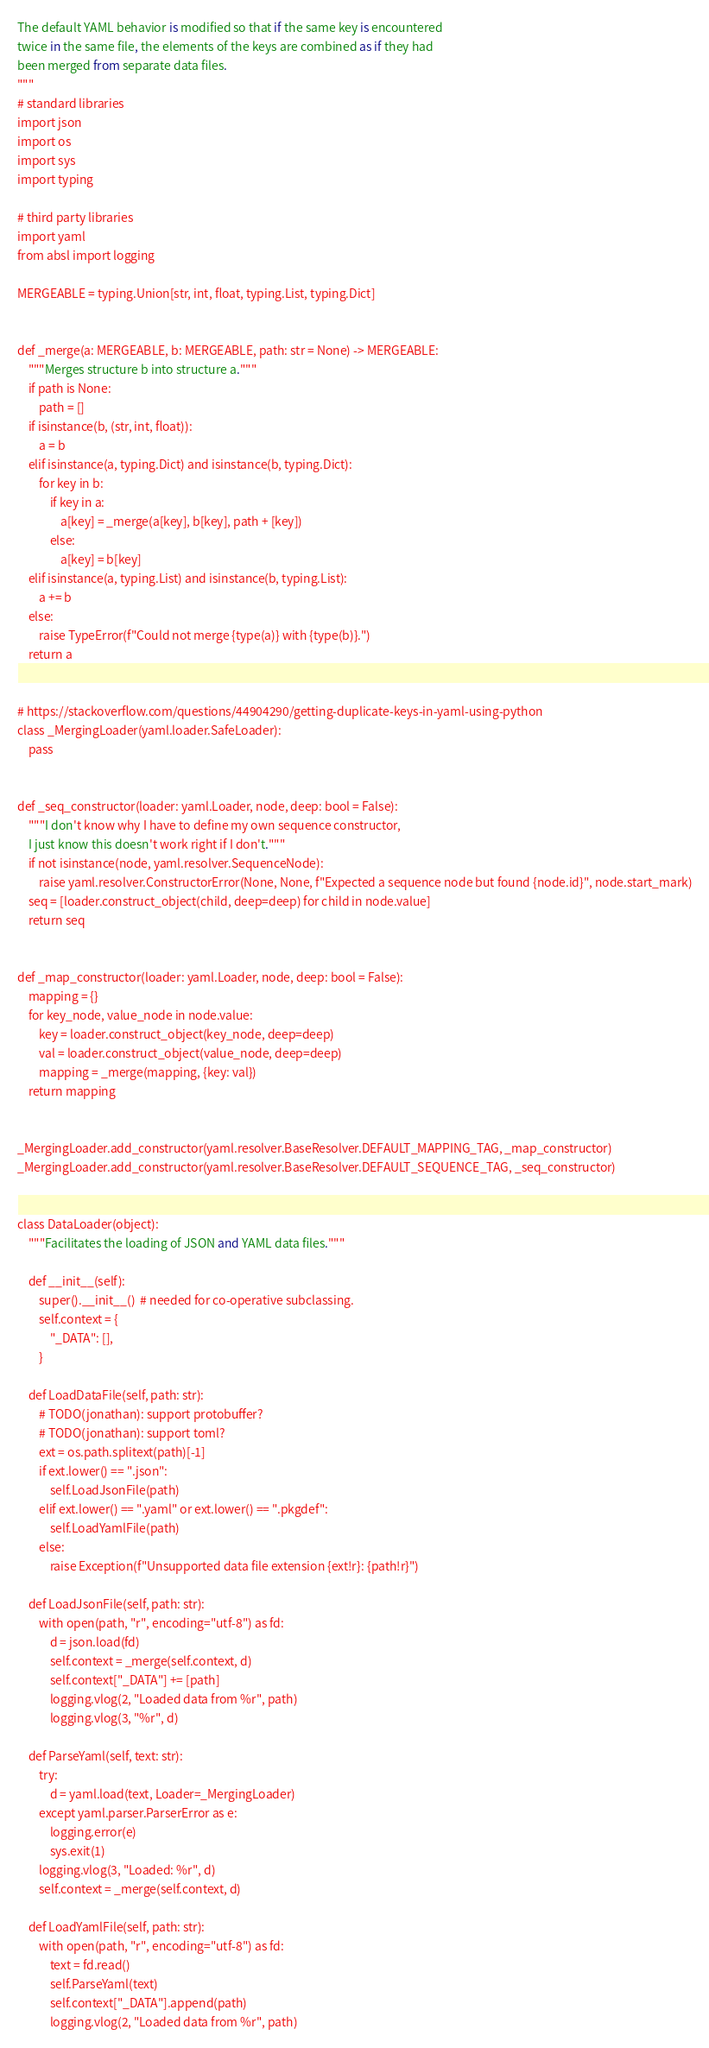<code> <loc_0><loc_0><loc_500><loc_500><_Python_>
The default YAML behavior is modified so that if the same key is encountered
twice in the same file, the elements of the keys are combined as if they had
been merged from separate data files.
"""
# standard libraries
import json
import os
import sys
import typing

# third party libraries
import yaml
from absl import logging

MERGEABLE = typing.Union[str, int, float, typing.List, typing.Dict]


def _merge(a: MERGEABLE, b: MERGEABLE, path: str = None) -> MERGEABLE:
    """Merges structure b into structure a."""
    if path is None:
        path = []
    if isinstance(b, (str, int, float)):
        a = b
    elif isinstance(a, typing.Dict) and isinstance(b, typing.Dict):
        for key in b:
            if key in a:
                a[key] = _merge(a[key], b[key], path + [key])
            else:
                a[key] = b[key]
    elif isinstance(a, typing.List) and isinstance(b, typing.List):
        a += b
    else:
        raise TypeError(f"Could not merge {type(a)} with {type(b)}.")
    return a


# https://stackoverflow.com/questions/44904290/getting-duplicate-keys-in-yaml-using-python
class _MergingLoader(yaml.loader.SafeLoader):
    pass


def _seq_constructor(loader: yaml.Loader, node, deep: bool = False):
    """I don't know why I have to define my own sequence constructor,
    I just know this doesn't work right if I don't."""
    if not isinstance(node, yaml.resolver.SequenceNode):
        raise yaml.resolver.ConstructorError(None, None, f"Expected a sequence node but found {node.id}", node.start_mark)
    seq = [loader.construct_object(child, deep=deep) for child in node.value]
    return seq


def _map_constructor(loader: yaml.Loader, node, deep: bool = False):
    mapping = {}
    for key_node, value_node in node.value:
        key = loader.construct_object(key_node, deep=deep)
        val = loader.construct_object(value_node, deep=deep)
        mapping = _merge(mapping, {key: val})
    return mapping


_MergingLoader.add_constructor(yaml.resolver.BaseResolver.DEFAULT_MAPPING_TAG, _map_constructor)
_MergingLoader.add_constructor(yaml.resolver.BaseResolver.DEFAULT_SEQUENCE_TAG, _seq_constructor)


class DataLoader(object):
    """Facilitates the loading of JSON and YAML data files."""

    def __init__(self):
        super().__init__()  # needed for co-operative subclassing.
        self.context = {
            "_DATA": [],
        }

    def LoadDataFile(self, path: str):
        # TODO(jonathan): support protobuffer?
        # TODO(jonathan): support toml?
        ext = os.path.splitext(path)[-1]
        if ext.lower() == ".json":
            self.LoadJsonFile(path)
        elif ext.lower() == ".yaml" or ext.lower() == ".pkgdef":
            self.LoadYamlFile(path)
        else:
            raise Exception(f"Unsupported data file extension {ext!r}: {path!r}")

    def LoadJsonFile(self, path: str):
        with open(path, "r", encoding="utf-8") as fd:
            d = json.load(fd)
            self.context = _merge(self.context, d)
            self.context["_DATA"] += [path]
            logging.vlog(2, "Loaded data from %r", path)
            logging.vlog(3, "%r", d)

    def ParseYaml(self, text: str):
        try:
            d = yaml.load(text, Loader=_MergingLoader)
        except yaml.parser.ParserError as e:
            logging.error(e)
            sys.exit(1)
        logging.vlog(3, "Loaded: %r", d)
        self.context = _merge(self.context, d)

    def LoadYamlFile(self, path: str):
        with open(path, "r", encoding="utf-8") as fd:
            text = fd.read()
            self.ParseYaml(text)
            self.context["_DATA"].append(path)
            logging.vlog(2, "Loaded data from %r", path)
</code> 